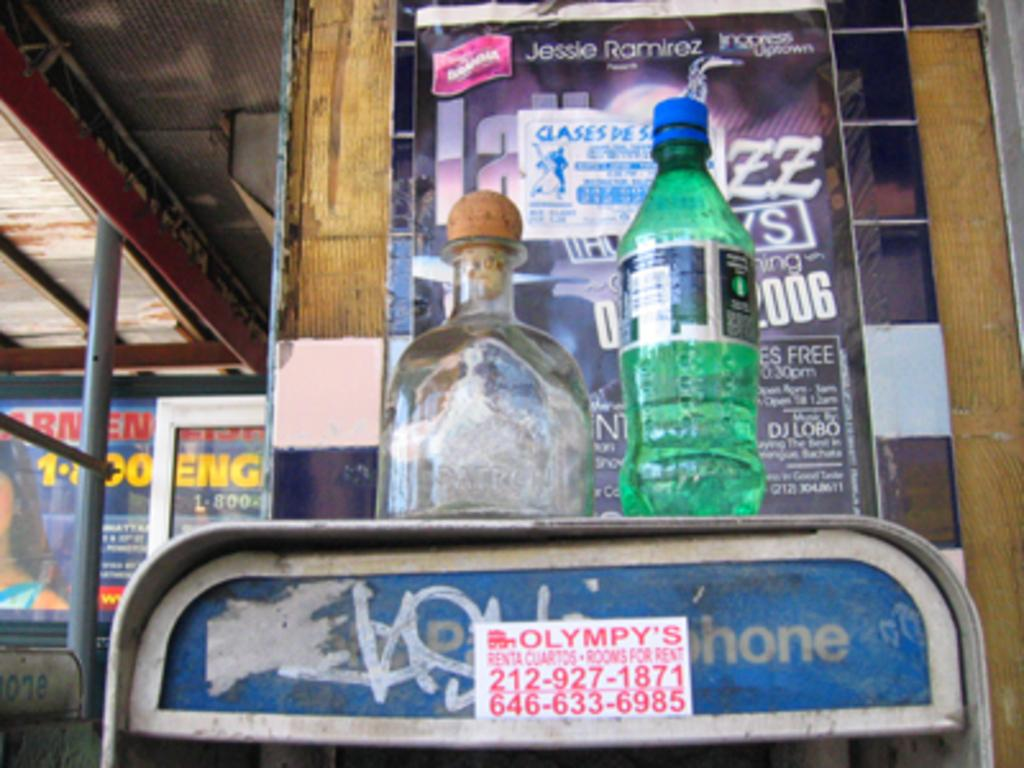How many bottles are visible in the image? There are two bottles in the image. What can be seen in the background of the image? There is a poster in the background of the image. What other object is present in the image? There is a pole in the image. What type of grass is growing around the bottles in the image? There is no grass visible in the image; it appears to be a different setting. 